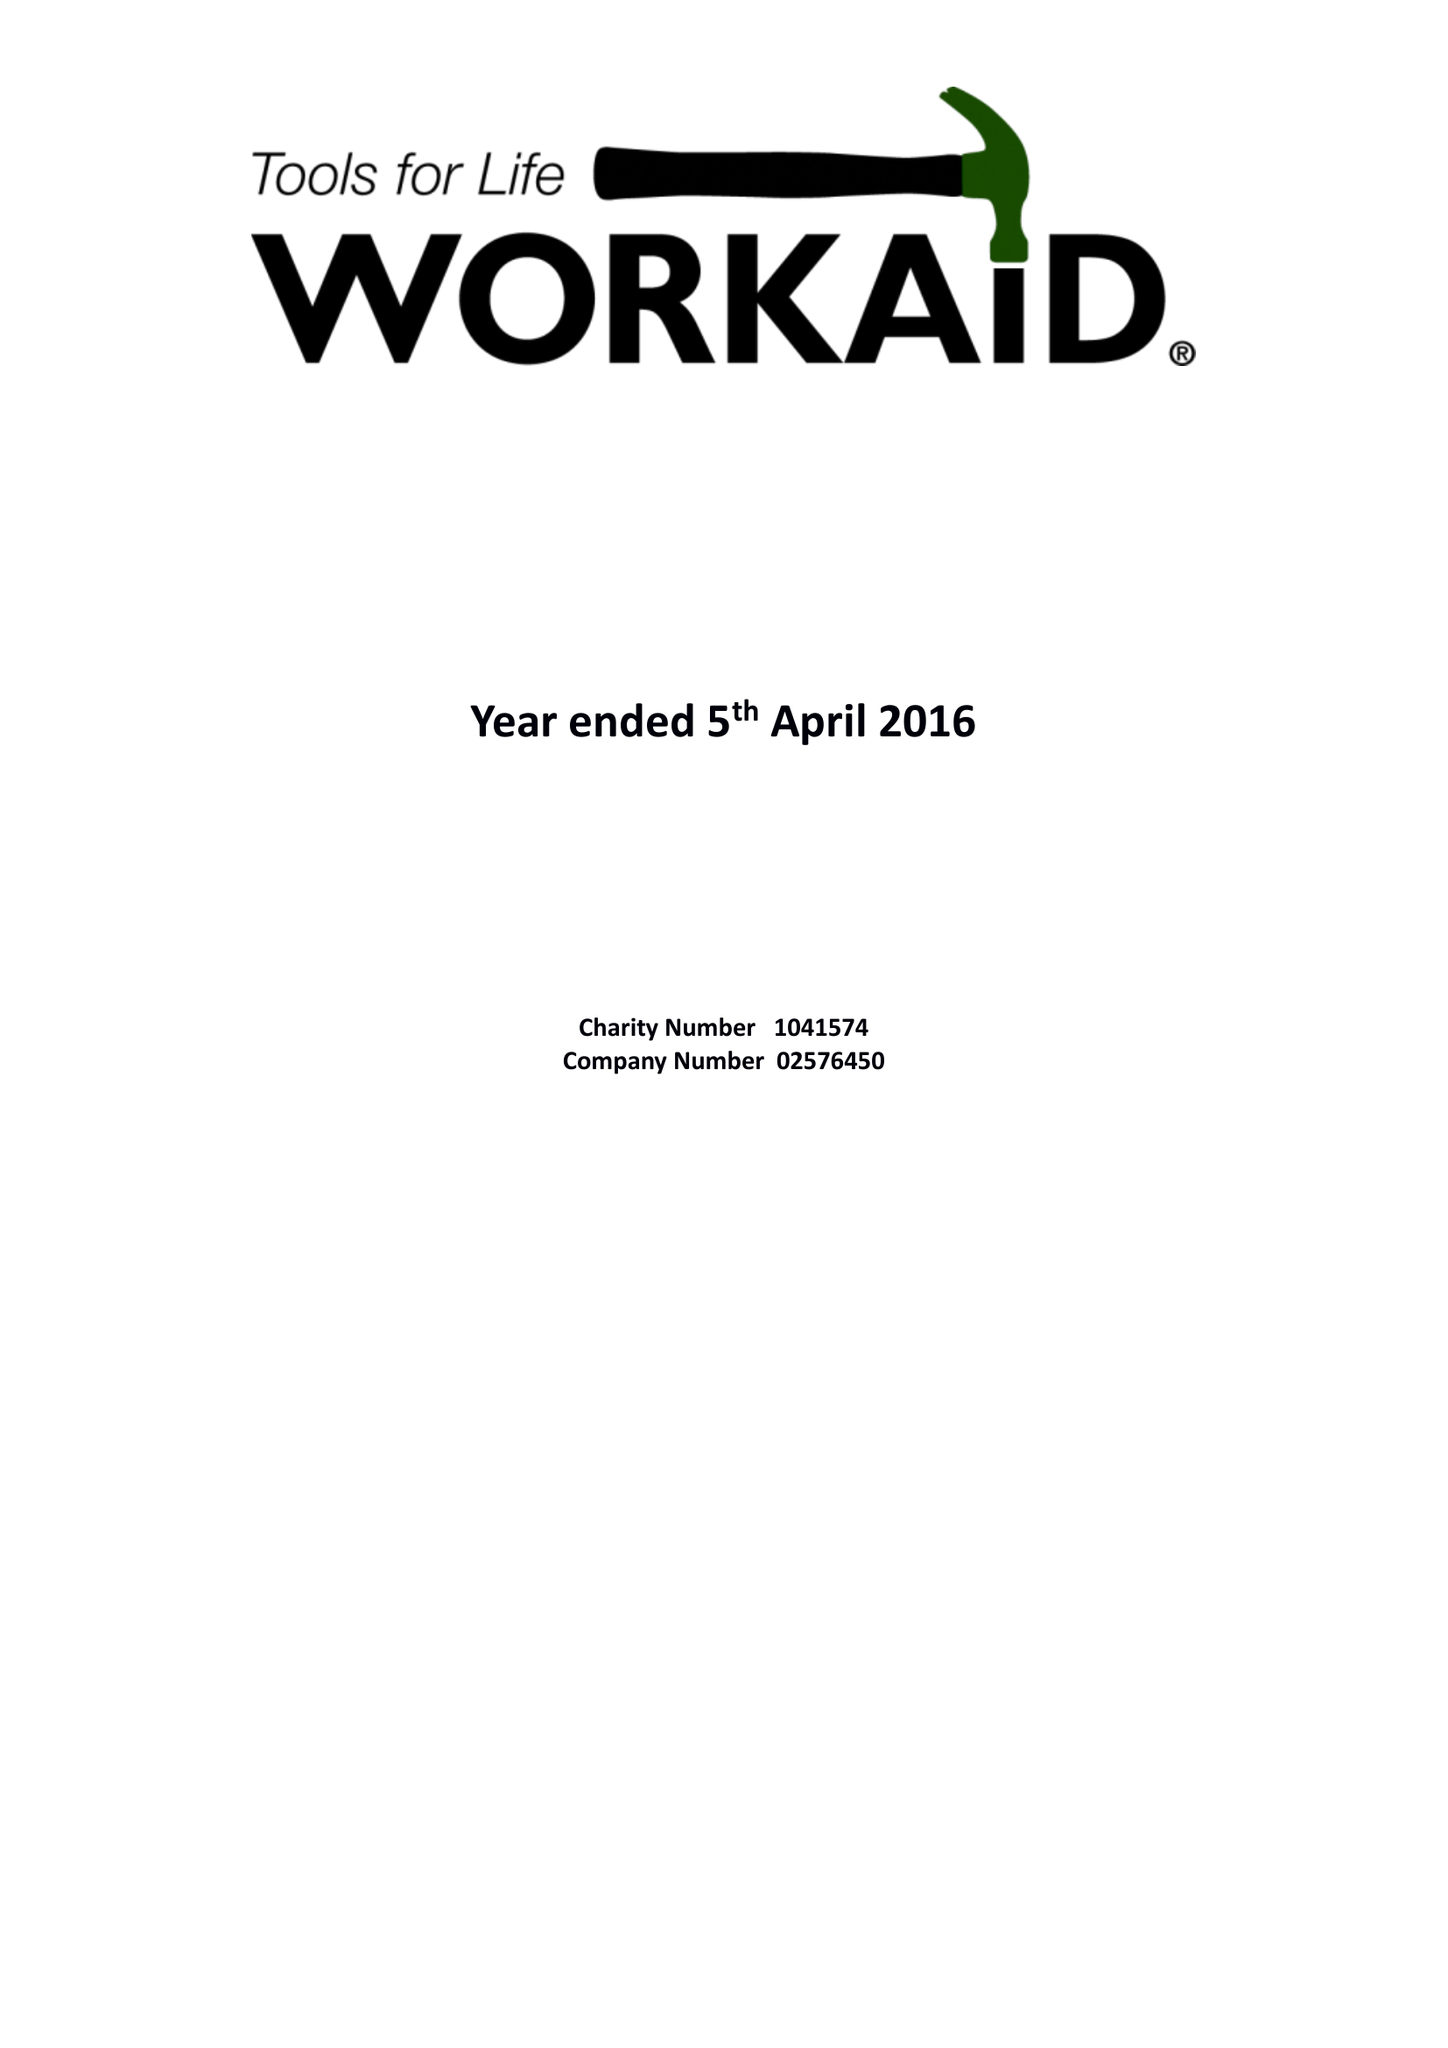What is the value for the address__street_line?
Answer the question using a single word or phrase. 71 TOWNSEND ROAD 